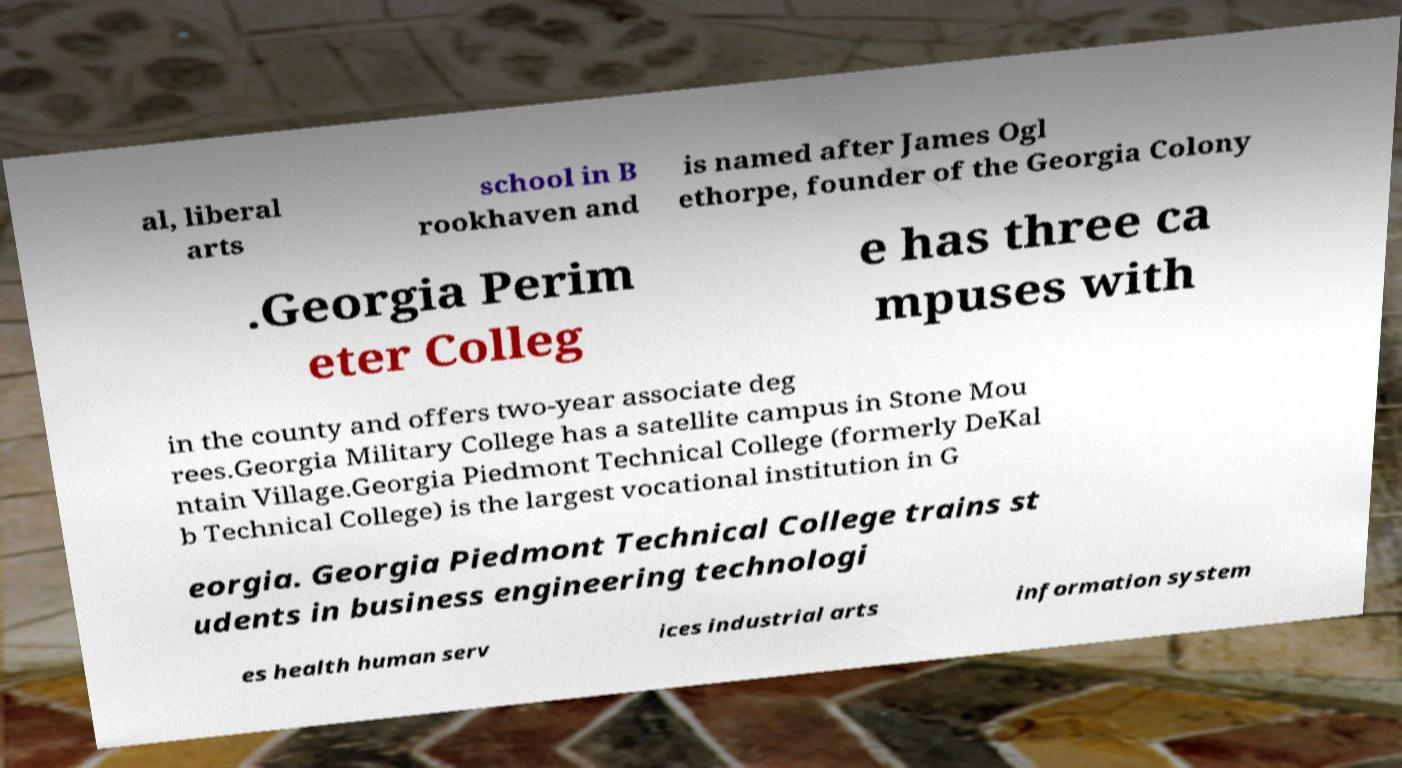I need the written content from this picture converted into text. Can you do that? al, liberal arts school in B rookhaven and is named after James Ogl ethorpe, founder of the Georgia Colony .Georgia Perim eter Colleg e has three ca mpuses with in the county and offers two-year associate deg rees.Georgia Military College has a satellite campus in Stone Mou ntain Village.Georgia Piedmont Technical College (formerly DeKal b Technical College) is the largest vocational institution in G eorgia. Georgia Piedmont Technical College trains st udents in business engineering technologi es health human serv ices industrial arts information system 